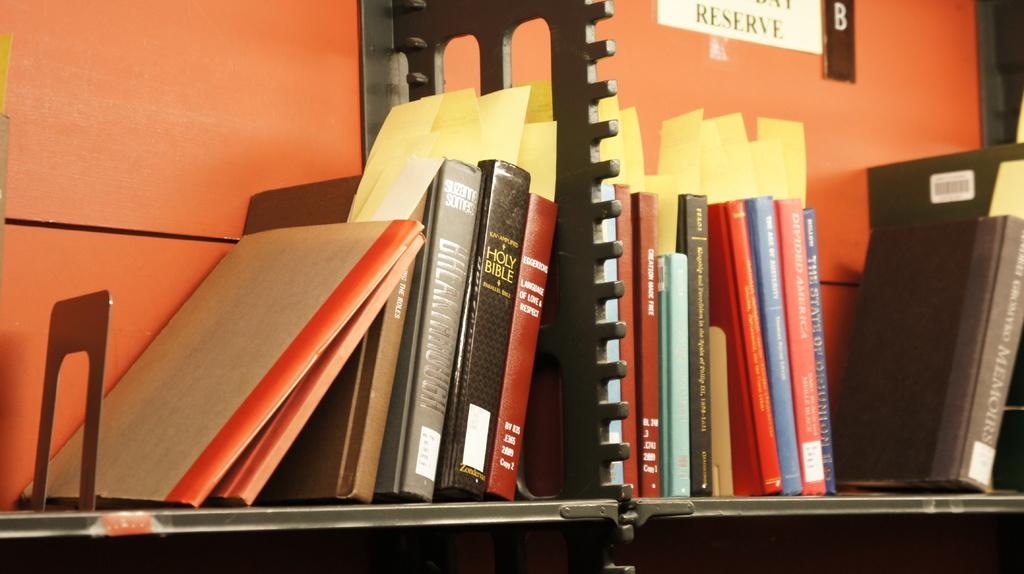What kind of bible is available on the shelf?
Give a very brief answer. Holy bible. What is the name of the holy black book?
Your response must be concise. Holy bible. 